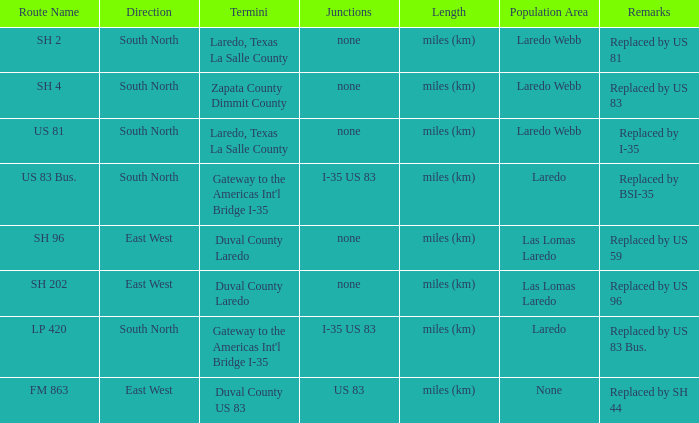Which routes have  "replaced by US 81" listed in their remarks section? SH 2. 